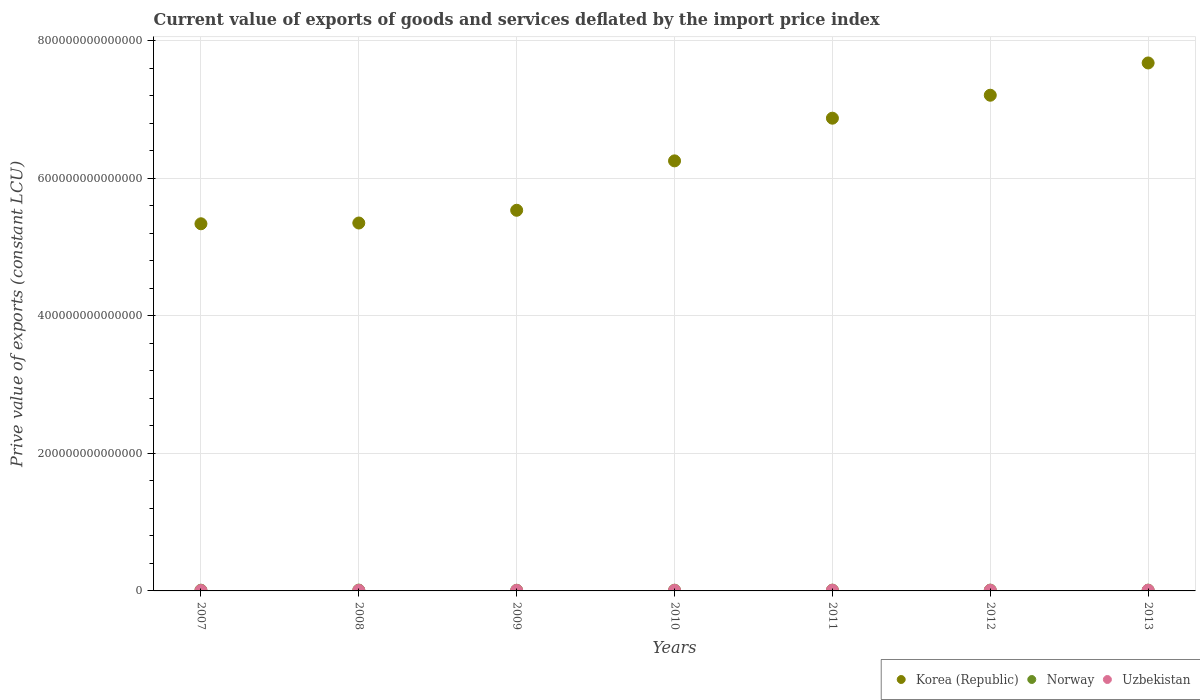What is the prive value of exports in Norway in 2013?
Ensure brevity in your answer.  1.12e+12. Across all years, what is the maximum prive value of exports in Uzbekistan?
Give a very brief answer. 1.02e+12. Across all years, what is the minimum prive value of exports in Uzbekistan?
Make the answer very short. 5.86e+11. In which year was the prive value of exports in Uzbekistan maximum?
Offer a very short reply. 2013. What is the total prive value of exports in Norway in the graph?
Provide a succinct answer. 7.67e+12. What is the difference between the prive value of exports in Norway in 2008 and that in 2013?
Give a very brief answer. 8.02e+1. What is the difference between the prive value of exports in Korea (Republic) in 2012 and the prive value of exports in Uzbekistan in 2010?
Make the answer very short. 7.20e+14. What is the average prive value of exports in Uzbekistan per year?
Provide a succinct answer. 8.49e+11. In the year 2009, what is the difference between the prive value of exports in Uzbekistan and prive value of exports in Korea (Republic)?
Ensure brevity in your answer.  -5.53e+14. In how many years, is the prive value of exports in Uzbekistan greater than 720000000000000 LCU?
Offer a very short reply. 0. What is the ratio of the prive value of exports in Norway in 2011 to that in 2013?
Your answer should be very brief. 0.99. What is the difference between the highest and the second highest prive value of exports in Korea (Republic)?
Your answer should be very brief. 4.69e+13. What is the difference between the highest and the lowest prive value of exports in Uzbekistan?
Offer a very short reply. 4.30e+11. Does the prive value of exports in Korea (Republic) monotonically increase over the years?
Your response must be concise. Yes. Is the prive value of exports in Korea (Republic) strictly greater than the prive value of exports in Norway over the years?
Keep it short and to the point. Yes. Is the prive value of exports in Uzbekistan strictly less than the prive value of exports in Norway over the years?
Offer a terse response. Yes. What is the difference between two consecutive major ticks on the Y-axis?
Provide a short and direct response. 2.00e+14. Are the values on the major ticks of Y-axis written in scientific E-notation?
Offer a terse response. No. Does the graph contain any zero values?
Make the answer very short. No. Does the graph contain grids?
Make the answer very short. Yes. How many legend labels are there?
Make the answer very short. 3. How are the legend labels stacked?
Ensure brevity in your answer.  Horizontal. What is the title of the graph?
Make the answer very short. Current value of exports of goods and services deflated by the import price index. Does "Chad" appear as one of the legend labels in the graph?
Keep it short and to the point. No. What is the label or title of the Y-axis?
Keep it short and to the point. Prive value of exports (constant LCU). What is the Prive value of exports (constant LCU) of Korea (Republic) in 2007?
Give a very brief answer. 5.34e+14. What is the Prive value of exports (constant LCU) in Norway in 2007?
Make the answer very short. 1.07e+12. What is the Prive value of exports (constant LCU) of Uzbekistan in 2007?
Your answer should be very brief. 5.86e+11. What is the Prive value of exports (constant LCU) in Korea (Republic) in 2008?
Offer a terse response. 5.35e+14. What is the Prive value of exports (constant LCU) in Norway in 2008?
Make the answer very short. 1.20e+12. What is the Prive value of exports (constant LCU) in Uzbekistan in 2008?
Your answer should be compact. 8.05e+11. What is the Prive value of exports (constant LCU) in Korea (Republic) in 2009?
Ensure brevity in your answer.  5.53e+14. What is the Prive value of exports (constant LCU) in Norway in 2009?
Ensure brevity in your answer.  9.60e+11. What is the Prive value of exports (constant LCU) in Uzbekistan in 2009?
Your response must be concise. 7.74e+11. What is the Prive value of exports (constant LCU) of Korea (Republic) in 2010?
Offer a terse response. 6.25e+14. What is the Prive value of exports (constant LCU) of Norway in 2010?
Offer a terse response. 1.03e+12. What is the Prive value of exports (constant LCU) in Uzbekistan in 2010?
Your response must be concise. 8.25e+11. What is the Prive value of exports (constant LCU) in Korea (Republic) in 2011?
Offer a very short reply. 6.87e+14. What is the Prive value of exports (constant LCU) of Norway in 2011?
Ensure brevity in your answer.  1.12e+12. What is the Prive value of exports (constant LCU) of Uzbekistan in 2011?
Ensure brevity in your answer.  9.94e+11. What is the Prive value of exports (constant LCU) of Korea (Republic) in 2012?
Offer a terse response. 7.21e+14. What is the Prive value of exports (constant LCU) of Norway in 2012?
Your answer should be very brief. 1.16e+12. What is the Prive value of exports (constant LCU) in Uzbekistan in 2012?
Offer a very short reply. 9.38e+11. What is the Prive value of exports (constant LCU) of Korea (Republic) in 2013?
Keep it short and to the point. 7.68e+14. What is the Prive value of exports (constant LCU) in Norway in 2013?
Make the answer very short. 1.12e+12. What is the Prive value of exports (constant LCU) of Uzbekistan in 2013?
Keep it short and to the point. 1.02e+12. Across all years, what is the maximum Prive value of exports (constant LCU) of Korea (Republic)?
Make the answer very short. 7.68e+14. Across all years, what is the maximum Prive value of exports (constant LCU) of Norway?
Offer a very short reply. 1.20e+12. Across all years, what is the maximum Prive value of exports (constant LCU) of Uzbekistan?
Your answer should be very brief. 1.02e+12. Across all years, what is the minimum Prive value of exports (constant LCU) in Korea (Republic)?
Your answer should be compact. 5.34e+14. Across all years, what is the minimum Prive value of exports (constant LCU) of Norway?
Your response must be concise. 9.60e+11. Across all years, what is the minimum Prive value of exports (constant LCU) in Uzbekistan?
Your answer should be very brief. 5.86e+11. What is the total Prive value of exports (constant LCU) of Korea (Republic) in the graph?
Your answer should be very brief. 4.42e+15. What is the total Prive value of exports (constant LCU) of Norway in the graph?
Give a very brief answer. 7.67e+12. What is the total Prive value of exports (constant LCU) in Uzbekistan in the graph?
Provide a succinct answer. 5.94e+12. What is the difference between the Prive value of exports (constant LCU) of Korea (Republic) in 2007 and that in 2008?
Offer a very short reply. -1.11e+12. What is the difference between the Prive value of exports (constant LCU) in Norway in 2007 and that in 2008?
Offer a very short reply. -1.37e+11. What is the difference between the Prive value of exports (constant LCU) in Uzbekistan in 2007 and that in 2008?
Ensure brevity in your answer.  -2.19e+11. What is the difference between the Prive value of exports (constant LCU) in Korea (Republic) in 2007 and that in 2009?
Provide a short and direct response. -1.96e+13. What is the difference between the Prive value of exports (constant LCU) in Norway in 2007 and that in 2009?
Ensure brevity in your answer.  1.06e+11. What is the difference between the Prive value of exports (constant LCU) of Uzbekistan in 2007 and that in 2009?
Keep it short and to the point. -1.87e+11. What is the difference between the Prive value of exports (constant LCU) of Korea (Republic) in 2007 and that in 2010?
Ensure brevity in your answer.  -9.15e+13. What is the difference between the Prive value of exports (constant LCU) in Norway in 2007 and that in 2010?
Provide a short and direct response. 3.46e+1. What is the difference between the Prive value of exports (constant LCU) of Uzbekistan in 2007 and that in 2010?
Offer a terse response. -2.39e+11. What is the difference between the Prive value of exports (constant LCU) in Korea (Republic) in 2007 and that in 2011?
Give a very brief answer. -1.54e+14. What is the difference between the Prive value of exports (constant LCU) of Norway in 2007 and that in 2011?
Make the answer very short. -5.07e+1. What is the difference between the Prive value of exports (constant LCU) in Uzbekistan in 2007 and that in 2011?
Provide a succinct answer. -4.07e+11. What is the difference between the Prive value of exports (constant LCU) of Korea (Republic) in 2007 and that in 2012?
Your answer should be compact. -1.87e+14. What is the difference between the Prive value of exports (constant LCU) in Norway in 2007 and that in 2012?
Offer a very short reply. -9.87e+1. What is the difference between the Prive value of exports (constant LCU) of Uzbekistan in 2007 and that in 2012?
Give a very brief answer. -3.52e+11. What is the difference between the Prive value of exports (constant LCU) of Korea (Republic) in 2007 and that in 2013?
Keep it short and to the point. -2.34e+14. What is the difference between the Prive value of exports (constant LCU) of Norway in 2007 and that in 2013?
Your answer should be very brief. -5.72e+1. What is the difference between the Prive value of exports (constant LCU) in Uzbekistan in 2007 and that in 2013?
Provide a short and direct response. -4.30e+11. What is the difference between the Prive value of exports (constant LCU) of Korea (Republic) in 2008 and that in 2009?
Ensure brevity in your answer.  -1.85e+13. What is the difference between the Prive value of exports (constant LCU) in Norway in 2008 and that in 2009?
Your answer should be compact. 2.43e+11. What is the difference between the Prive value of exports (constant LCU) of Uzbekistan in 2008 and that in 2009?
Make the answer very short. 3.17e+1. What is the difference between the Prive value of exports (constant LCU) in Korea (Republic) in 2008 and that in 2010?
Keep it short and to the point. -9.04e+13. What is the difference between the Prive value of exports (constant LCU) of Norway in 2008 and that in 2010?
Offer a very short reply. 1.72e+11. What is the difference between the Prive value of exports (constant LCU) in Uzbekistan in 2008 and that in 2010?
Provide a succinct answer. -1.95e+1. What is the difference between the Prive value of exports (constant LCU) in Korea (Republic) in 2008 and that in 2011?
Your answer should be compact. -1.52e+14. What is the difference between the Prive value of exports (constant LCU) of Norway in 2008 and that in 2011?
Ensure brevity in your answer.  8.67e+1. What is the difference between the Prive value of exports (constant LCU) in Uzbekistan in 2008 and that in 2011?
Give a very brief answer. -1.88e+11. What is the difference between the Prive value of exports (constant LCU) in Korea (Republic) in 2008 and that in 2012?
Offer a very short reply. -1.86e+14. What is the difference between the Prive value of exports (constant LCU) of Norway in 2008 and that in 2012?
Give a very brief answer. 3.87e+1. What is the difference between the Prive value of exports (constant LCU) in Uzbekistan in 2008 and that in 2012?
Give a very brief answer. -1.33e+11. What is the difference between the Prive value of exports (constant LCU) in Korea (Republic) in 2008 and that in 2013?
Provide a succinct answer. -2.33e+14. What is the difference between the Prive value of exports (constant LCU) in Norway in 2008 and that in 2013?
Your response must be concise. 8.02e+1. What is the difference between the Prive value of exports (constant LCU) in Uzbekistan in 2008 and that in 2013?
Your answer should be compact. -2.11e+11. What is the difference between the Prive value of exports (constant LCU) of Korea (Republic) in 2009 and that in 2010?
Keep it short and to the point. -7.18e+13. What is the difference between the Prive value of exports (constant LCU) of Norway in 2009 and that in 2010?
Keep it short and to the point. -7.09e+1. What is the difference between the Prive value of exports (constant LCU) of Uzbekistan in 2009 and that in 2010?
Make the answer very short. -5.12e+1. What is the difference between the Prive value of exports (constant LCU) of Korea (Republic) in 2009 and that in 2011?
Offer a terse response. -1.34e+14. What is the difference between the Prive value of exports (constant LCU) of Norway in 2009 and that in 2011?
Ensure brevity in your answer.  -1.56e+11. What is the difference between the Prive value of exports (constant LCU) of Uzbekistan in 2009 and that in 2011?
Provide a succinct answer. -2.20e+11. What is the difference between the Prive value of exports (constant LCU) in Korea (Republic) in 2009 and that in 2012?
Your answer should be compact. -1.67e+14. What is the difference between the Prive value of exports (constant LCU) in Norway in 2009 and that in 2012?
Offer a terse response. -2.04e+11. What is the difference between the Prive value of exports (constant LCU) in Uzbekistan in 2009 and that in 2012?
Give a very brief answer. -1.65e+11. What is the difference between the Prive value of exports (constant LCU) of Korea (Republic) in 2009 and that in 2013?
Offer a very short reply. -2.14e+14. What is the difference between the Prive value of exports (constant LCU) of Norway in 2009 and that in 2013?
Offer a very short reply. -1.63e+11. What is the difference between the Prive value of exports (constant LCU) in Uzbekistan in 2009 and that in 2013?
Give a very brief answer. -2.43e+11. What is the difference between the Prive value of exports (constant LCU) in Korea (Republic) in 2010 and that in 2011?
Provide a short and direct response. -6.21e+13. What is the difference between the Prive value of exports (constant LCU) in Norway in 2010 and that in 2011?
Provide a short and direct response. -8.54e+1. What is the difference between the Prive value of exports (constant LCU) of Uzbekistan in 2010 and that in 2011?
Give a very brief answer. -1.69e+11. What is the difference between the Prive value of exports (constant LCU) in Korea (Republic) in 2010 and that in 2012?
Give a very brief answer. -9.54e+13. What is the difference between the Prive value of exports (constant LCU) in Norway in 2010 and that in 2012?
Make the answer very short. -1.33e+11. What is the difference between the Prive value of exports (constant LCU) of Uzbekistan in 2010 and that in 2012?
Your answer should be compact. -1.14e+11. What is the difference between the Prive value of exports (constant LCU) in Korea (Republic) in 2010 and that in 2013?
Give a very brief answer. -1.42e+14. What is the difference between the Prive value of exports (constant LCU) of Norway in 2010 and that in 2013?
Provide a short and direct response. -9.18e+1. What is the difference between the Prive value of exports (constant LCU) of Uzbekistan in 2010 and that in 2013?
Give a very brief answer. -1.92e+11. What is the difference between the Prive value of exports (constant LCU) of Korea (Republic) in 2011 and that in 2012?
Offer a terse response. -3.34e+13. What is the difference between the Prive value of exports (constant LCU) of Norway in 2011 and that in 2012?
Your answer should be very brief. -4.80e+1. What is the difference between the Prive value of exports (constant LCU) of Uzbekistan in 2011 and that in 2012?
Provide a short and direct response. 5.53e+1. What is the difference between the Prive value of exports (constant LCU) of Korea (Republic) in 2011 and that in 2013?
Your answer should be very brief. -8.03e+13. What is the difference between the Prive value of exports (constant LCU) of Norway in 2011 and that in 2013?
Ensure brevity in your answer.  -6.43e+09. What is the difference between the Prive value of exports (constant LCU) of Uzbekistan in 2011 and that in 2013?
Give a very brief answer. -2.29e+1. What is the difference between the Prive value of exports (constant LCU) in Korea (Republic) in 2012 and that in 2013?
Offer a terse response. -4.69e+13. What is the difference between the Prive value of exports (constant LCU) in Norway in 2012 and that in 2013?
Ensure brevity in your answer.  4.16e+1. What is the difference between the Prive value of exports (constant LCU) of Uzbekistan in 2012 and that in 2013?
Provide a short and direct response. -7.82e+1. What is the difference between the Prive value of exports (constant LCU) in Korea (Republic) in 2007 and the Prive value of exports (constant LCU) in Norway in 2008?
Your response must be concise. 5.33e+14. What is the difference between the Prive value of exports (constant LCU) in Korea (Republic) in 2007 and the Prive value of exports (constant LCU) in Uzbekistan in 2008?
Ensure brevity in your answer.  5.33e+14. What is the difference between the Prive value of exports (constant LCU) in Norway in 2007 and the Prive value of exports (constant LCU) in Uzbekistan in 2008?
Ensure brevity in your answer.  2.61e+11. What is the difference between the Prive value of exports (constant LCU) of Korea (Republic) in 2007 and the Prive value of exports (constant LCU) of Norway in 2009?
Offer a terse response. 5.33e+14. What is the difference between the Prive value of exports (constant LCU) in Korea (Republic) in 2007 and the Prive value of exports (constant LCU) in Uzbekistan in 2009?
Offer a terse response. 5.33e+14. What is the difference between the Prive value of exports (constant LCU) of Norway in 2007 and the Prive value of exports (constant LCU) of Uzbekistan in 2009?
Make the answer very short. 2.92e+11. What is the difference between the Prive value of exports (constant LCU) in Korea (Republic) in 2007 and the Prive value of exports (constant LCU) in Norway in 2010?
Your answer should be very brief. 5.33e+14. What is the difference between the Prive value of exports (constant LCU) of Korea (Republic) in 2007 and the Prive value of exports (constant LCU) of Uzbekistan in 2010?
Your answer should be compact. 5.33e+14. What is the difference between the Prive value of exports (constant LCU) in Norway in 2007 and the Prive value of exports (constant LCU) in Uzbekistan in 2010?
Give a very brief answer. 2.41e+11. What is the difference between the Prive value of exports (constant LCU) in Korea (Republic) in 2007 and the Prive value of exports (constant LCU) in Norway in 2011?
Make the answer very short. 5.33e+14. What is the difference between the Prive value of exports (constant LCU) of Korea (Republic) in 2007 and the Prive value of exports (constant LCU) of Uzbekistan in 2011?
Offer a very short reply. 5.33e+14. What is the difference between the Prive value of exports (constant LCU) of Norway in 2007 and the Prive value of exports (constant LCU) of Uzbekistan in 2011?
Make the answer very short. 7.22e+1. What is the difference between the Prive value of exports (constant LCU) of Korea (Republic) in 2007 and the Prive value of exports (constant LCU) of Norway in 2012?
Keep it short and to the point. 5.33e+14. What is the difference between the Prive value of exports (constant LCU) of Korea (Republic) in 2007 and the Prive value of exports (constant LCU) of Uzbekistan in 2012?
Provide a succinct answer. 5.33e+14. What is the difference between the Prive value of exports (constant LCU) of Norway in 2007 and the Prive value of exports (constant LCU) of Uzbekistan in 2012?
Ensure brevity in your answer.  1.27e+11. What is the difference between the Prive value of exports (constant LCU) in Korea (Republic) in 2007 and the Prive value of exports (constant LCU) in Norway in 2013?
Provide a succinct answer. 5.33e+14. What is the difference between the Prive value of exports (constant LCU) in Korea (Republic) in 2007 and the Prive value of exports (constant LCU) in Uzbekistan in 2013?
Your answer should be compact. 5.33e+14. What is the difference between the Prive value of exports (constant LCU) in Norway in 2007 and the Prive value of exports (constant LCU) in Uzbekistan in 2013?
Ensure brevity in your answer.  4.93e+1. What is the difference between the Prive value of exports (constant LCU) of Korea (Republic) in 2008 and the Prive value of exports (constant LCU) of Norway in 2009?
Give a very brief answer. 5.34e+14. What is the difference between the Prive value of exports (constant LCU) of Korea (Republic) in 2008 and the Prive value of exports (constant LCU) of Uzbekistan in 2009?
Your response must be concise. 5.34e+14. What is the difference between the Prive value of exports (constant LCU) in Norway in 2008 and the Prive value of exports (constant LCU) in Uzbekistan in 2009?
Offer a very short reply. 4.30e+11. What is the difference between the Prive value of exports (constant LCU) of Korea (Republic) in 2008 and the Prive value of exports (constant LCU) of Norway in 2010?
Keep it short and to the point. 5.34e+14. What is the difference between the Prive value of exports (constant LCU) in Korea (Republic) in 2008 and the Prive value of exports (constant LCU) in Uzbekistan in 2010?
Ensure brevity in your answer.  5.34e+14. What is the difference between the Prive value of exports (constant LCU) of Norway in 2008 and the Prive value of exports (constant LCU) of Uzbekistan in 2010?
Offer a terse response. 3.78e+11. What is the difference between the Prive value of exports (constant LCU) in Korea (Republic) in 2008 and the Prive value of exports (constant LCU) in Norway in 2011?
Give a very brief answer. 5.34e+14. What is the difference between the Prive value of exports (constant LCU) of Korea (Republic) in 2008 and the Prive value of exports (constant LCU) of Uzbekistan in 2011?
Provide a succinct answer. 5.34e+14. What is the difference between the Prive value of exports (constant LCU) in Norway in 2008 and the Prive value of exports (constant LCU) in Uzbekistan in 2011?
Your answer should be compact. 2.10e+11. What is the difference between the Prive value of exports (constant LCU) of Korea (Republic) in 2008 and the Prive value of exports (constant LCU) of Norway in 2012?
Your response must be concise. 5.34e+14. What is the difference between the Prive value of exports (constant LCU) of Korea (Republic) in 2008 and the Prive value of exports (constant LCU) of Uzbekistan in 2012?
Keep it short and to the point. 5.34e+14. What is the difference between the Prive value of exports (constant LCU) in Norway in 2008 and the Prive value of exports (constant LCU) in Uzbekistan in 2012?
Give a very brief answer. 2.65e+11. What is the difference between the Prive value of exports (constant LCU) in Korea (Republic) in 2008 and the Prive value of exports (constant LCU) in Norway in 2013?
Provide a succinct answer. 5.34e+14. What is the difference between the Prive value of exports (constant LCU) of Korea (Republic) in 2008 and the Prive value of exports (constant LCU) of Uzbekistan in 2013?
Your answer should be compact. 5.34e+14. What is the difference between the Prive value of exports (constant LCU) in Norway in 2008 and the Prive value of exports (constant LCU) in Uzbekistan in 2013?
Ensure brevity in your answer.  1.87e+11. What is the difference between the Prive value of exports (constant LCU) of Korea (Republic) in 2009 and the Prive value of exports (constant LCU) of Norway in 2010?
Keep it short and to the point. 5.52e+14. What is the difference between the Prive value of exports (constant LCU) in Korea (Republic) in 2009 and the Prive value of exports (constant LCU) in Uzbekistan in 2010?
Keep it short and to the point. 5.53e+14. What is the difference between the Prive value of exports (constant LCU) in Norway in 2009 and the Prive value of exports (constant LCU) in Uzbekistan in 2010?
Offer a terse response. 1.35e+11. What is the difference between the Prive value of exports (constant LCU) in Korea (Republic) in 2009 and the Prive value of exports (constant LCU) in Norway in 2011?
Your answer should be compact. 5.52e+14. What is the difference between the Prive value of exports (constant LCU) in Korea (Republic) in 2009 and the Prive value of exports (constant LCU) in Uzbekistan in 2011?
Give a very brief answer. 5.52e+14. What is the difference between the Prive value of exports (constant LCU) in Norway in 2009 and the Prive value of exports (constant LCU) in Uzbekistan in 2011?
Your response must be concise. -3.33e+1. What is the difference between the Prive value of exports (constant LCU) in Korea (Republic) in 2009 and the Prive value of exports (constant LCU) in Norway in 2012?
Provide a succinct answer. 5.52e+14. What is the difference between the Prive value of exports (constant LCU) in Korea (Republic) in 2009 and the Prive value of exports (constant LCU) in Uzbekistan in 2012?
Your answer should be very brief. 5.53e+14. What is the difference between the Prive value of exports (constant LCU) of Norway in 2009 and the Prive value of exports (constant LCU) of Uzbekistan in 2012?
Ensure brevity in your answer.  2.20e+1. What is the difference between the Prive value of exports (constant LCU) of Korea (Republic) in 2009 and the Prive value of exports (constant LCU) of Norway in 2013?
Your answer should be very brief. 5.52e+14. What is the difference between the Prive value of exports (constant LCU) in Korea (Republic) in 2009 and the Prive value of exports (constant LCU) in Uzbekistan in 2013?
Keep it short and to the point. 5.52e+14. What is the difference between the Prive value of exports (constant LCU) of Norway in 2009 and the Prive value of exports (constant LCU) of Uzbekistan in 2013?
Your answer should be very brief. -5.62e+1. What is the difference between the Prive value of exports (constant LCU) of Korea (Republic) in 2010 and the Prive value of exports (constant LCU) of Norway in 2011?
Ensure brevity in your answer.  6.24e+14. What is the difference between the Prive value of exports (constant LCU) of Korea (Republic) in 2010 and the Prive value of exports (constant LCU) of Uzbekistan in 2011?
Offer a terse response. 6.24e+14. What is the difference between the Prive value of exports (constant LCU) of Norway in 2010 and the Prive value of exports (constant LCU) of Uzbekistan in 2011?
Your answer should be compact. 3.76e+1. What is the difference between the Prive value of exports (constant LCU) in Korea (Republic) in 2010 and the Prive value of exports (constant LCU) in Norway in 2012?
Provide a short and direct response. 6.24e+14. What is the difference between the Prive value of exports (constant LCU) of Korea (Republic) in 2010 and the Prive value of exports (constant LCU) of Uzbekistan in 2012?
Offer a very short reply. 6.24e+14. What is the difference between the Prive value of exports (constant LCU) in Norway in 2010 and the Prive value of exports (constant LCU) in Uzbekistan in 2012?
Provide a succinct answer. 9.29e+1. What is the difference between the Prive value of exports (constant LCU) in Korea (Republic) in 2010 and the Prive value of exports (constant LCU) in Norway in 2013?
Offer a terse response. 6.24e+14. What is the difference between the Prive value of exports (constant LCU) in Korea (Republic) in 2010 and the Prive value of exports (constant LCU) in Uzbekistan in 2013?
Give a very brief answer. 6.24e+14. What is the difference between the Prive value of exports (constant LCU) of Norway in 2010 and the Prive value of exports (constant LCU) of Uzbekistan in 2013?
Give a very brief answer. 1.47e+1. What is the difference between the Prive value of exports (constant LCU) of Korea (Republic) in 2011 and the Prive value of exports (constant LCU) of Norway in 2012?
Your response must be concise. 6.86e+14. What is the difference between the Prive value of exports (constant LCU) of Korea (Republic) in 2011 and the Prive value of exports (constant LCU) of Uzbekistan in 2012?
Provide a succinct answer. 6.86e+14. What is the difference between the Prive value of exports (constant LCU) of Norway in 2011 and the Prive value of exports (constant LCU) of Uzbekistan in 2012?
Your answer should be very brief. 1.78e+11. What is the difference between the Prive value of exports (constant LCU) in Korea (Republic) in 2011 and the Prive value of exports (constant LCU) in Norway in 2013?
Make the answer very short. 6.86e+14. What is the difference between the Prive value of exports (constant LCU) in Korea (Republic) in 2011 and the Prive value of exports (constant LCU) in Uzbekistan in 2013?
Your response must be concise. 6.86e+14. What is the difference between the Prive value of exports (constant LCU) of Norway in 2011 and the Prive value of exports (constant LCU) of Uzbekistan in 2013?
Give a very brief answer. 1.00e+11. What is the difference between the Prive value of exports (constant LCU) in Korea (Republic) in 2012 and the Prive value of exports (constant LCU) in Norway in 2013?
Make the answer very short. 7.20e+14. What is the difference between the Prive value of exports (constant LCU) of Korea (Republic) in 2012 and the Prive value of exports (constant LCU) of Uzbekistan in 2013?
Your response must be concise. 7.20e+14. What is the difference between the Prive value of exports (constant LCU) of Norway in 2012 and the Prive value of exports (constant LCU) of Uzbekistan in 2013?
Your response must be concise. 1.48e+11. What is the average Prive value of exports (constant LCU) in Korea (Republic) per year?
Give a very brief answer. 6.32e+14. What is the average Prive value of exports (constant LCU) of Norway per year?
Your answer should be very brief. 1.10e+12. What is the average Prive value of exports (constant LCU) in Uzbekistan per year?
Offer a very short reply. 8.49e+11. In the year 2007, what is the difference between the Prive value of exports (constant LCU) of Korea (Republic) and Prive value of exports (constant LCU) of Norway?
Make the answer very short. 5.33e+14. In the year 2007, what is the difference between the Prive value of exports (constant LCU) in Korea (Republic) and Prive value of exports (constant LCU) in Uzbekistan?
Provide a succinct answer. 5.33e+14. In the year 2007, what is the difference between the Prive value of exports (constant LCU) in Norway and Prive value of exports (constant LCU) in Uzbekistan?
Keep it short and to the point. 4.80e+11. In the year 2008, what is the difference between the Prive value of exports (constant LCU) in Korea (Republic) and Prive value of exports (constant LCU) in Norway?
Keep it short and to the point. 5.34e+14. In the year 2008, what is the difference between the Prive value of exports (constant LCU) in Korea (Republic) and Prive value of exports (constant LCU) in Uzbekistan?
Your answer should be very brief. 5.34e+14. In the year 2008, what is the difference between the Prive value of exports (constant LCU) of Norway and Prive value of exports (constant LCU) of Uzbekistan?
Offer a very short reply. 3.98e+11. In the year 2009, what is the difference between the Prive value of exports (constant LCU) of Korea (Republic) and Prive value of exports (constant LCU) of Norway?
Provide a succinct answer. 5.53e+14. In the year 2009, what is the difference between the Prive value of exports (constant LCU) in Korea (Republic) and Prive value of exports (constant LCU) in Uzbekistan?
Your answer should be very brief. 5.53e+14. In the year 2009, what is the difference between the Prive value of exports (constant LCU) in Norway and Prive value of exports (constant LCU) in Uzbekistan?
Give a very brief answer. 1.87e+11. In the year 2010, what is the difference between the Prive value of exports (constant LCU) in Korea (Republic) and Prive value of exports (constant LCU) in Norway?
Give a very brief answer. 6.24e+14. In the year 2010, what is the difference between the Prive value of exports (constant LCU) in Korea (Republic) and Prive value of exports (constant LCU) in Uzbekistan?
Ensure brevity in your answer.  6.24e+14. In the year 2010, what is the difference between the Prive value of exports (constant LCU) of Norway and Prive value of exports (constant LCU) of Uzbekistan?
Ensure brevity in your answer.  2.06e+11. In the year 2011, what is the difference between the Prive value of exports (constant LCU) of Korea (Republic) and Prive value of exports (constant LCU) of Norway?
Your answer should be compact. 6.86e+14. In the year 2011, what is the difference between the Prive value of exports (constant LCU) of Korea (Republic) and Prive value of exports (constant LCU) of Uzbekistan?
Your response must be concise. 6.86e+14. In the year 2011, what is the difference between the Prive value of exports (constant LCU) in Norway and Prive value of exports (constant LCU) in Uzbekistan?
Give a very brief answer. 1.23e+11. In the year 2012, what is the difference between the Prive value of exports (constant LCU) in Korea (Republic) and Prive value of exports (constant LCU) in Norway?
Offer a very short reply. 7.20e+14. In the year 2012, what is the difference between the Prive value of exports (constant LCU) of Korea (Republic) and Prive value of exports (constant LCU) of Uzbekistan?
Offer a terse response. 7.20e+14. In the year 2012, what is the difference between the Prive value of exports (constant LCU) of Norway and Prive value of exports (constant LCU) of Uzbekistan?
Make the answer very short. 2.26e+11. In the year 2013, what is the difference between the Prive value of exports (constant LCU) of Korea (Republic) and Prive value of exports (constant LCU) of Norway?
Keep it short and to the point. 7.67e+14. In the year 2013, what is the difference between the Prive value of exports (constant LCU) in Korea (Republic) and Prive value of exports (constant LCU) in Uzbekistan?
Make the answer very short. 7.67e+14. In the year 2013, what is the difference between the Prive value of exports (constant LCU) of Norway and Prive value of exports (constant LCU) of Uzbekistan?
Ensure brevity in your answer.  1.06e+11. What is the ratio of the Prive value of exports (constant LCU) in Norway in 2007 to that in 2008?
Ensure brevity in your answer.  0.89. What is the ratio of the Prive value of exports (constant LCU) in Uzbekistan in 2007 to that in 2008?
Your response must be concise. 0.73. What is the ratio of the Prive value of exports (constant LCU) of Korea (Republic) in 2007 to that in 2009?
Your answer should be very brief. 0.96. What is the ratio of the Prive value of exports (constant LCU) in Norway in 2007 to that in 2009?
Offer a very short reply. 1.11. What is the ratio of the Prive value of exports (constant LCU) of Uzbekistan in 2007 to that in 2009?
Keep it short and to the point. 0.76. What is the ratio of the Prive value of exports (constant LCU) of Korea (Republic) in 2007 to that in 2010?
Make the answer very short. 0.85. What is the ratio of the Prive value of exports (constant LCU) in Norway in 2007 to that in 2010?
Make the answer very short. 1.03. What is the ratio of the Prive value of exports (constant LCU) of Uzbekistan in 2007 to that in 2010?
Offer a very short reply. 0.71. What is the ratio of the Prive value of exports (constant LCU) in Korea (Republic) in 2007 to that in 2011?
Ensure brevity in your answer.  0.78. What is the ratio of the Prive value of exports (constant LCU) in Norway in 2007 to that in 2011?
Give a very brief answer. 0.95. What is the ratio of the Prive value of exports (constant LCU) of Uzbekistan in 2007 to that in 2011?
Provide a succinct answer. 0.59. What is the ratio of the Prive value of exports (constant LCU) of Korea (Republic) in 2007 to that in 2012?
Your answer should be compact. 0.74. What is the ratio of the Prive value of exports (constant LCU) in Norway in 2007 to that in 2012?
Offer a very short reply. 0.92. What is the ratio of the Prive value of exports (constant LCU) in Uzbekistan in 2007 to that in 2012?
Make the answer very short. 0.62. What is the ratio of the Prive value of exports (constant LCU) in Korea (Republic) in 2007 to that in 2013?
Offer a very short reply. 0.7. What is the ratio of the Prive value of exports (constant LCU) of Norway in 2007 to that in 2013?
Give a very brief answer. 0.95. What is the ratio of the Prive value of exports (constant LCU) of Uzbekistan in 2007 to that in 2013?
Keep it short and to the point. 0.58. What is the ratio of the Prive value of exports (constant LCU) of Korea (Republic) in 2008 to that in 2009?
Your answer should be very brief. 0.97. What is the ratio of the Prive value of exports (constant LCU) of Norway in 2008 to that in 2009?
Give a very brief answer. 1.25. What is the ratio of the Prive value of exports (constant LCU) in Uzbekistan in 2008 to that in 2009?
Provide a succinct answer. 1.04. What is the ratio of the Prive value of exports (constant LCU) of Korea (Republic) in 2008 to that in 2010?
Your response must be concise. 0.86. What is the ratio of the Prive value of exports (constant LCU) of Norway in 2008 to that in 2010?
Provide a succinct answer. 1.17. What is the ratio of the Prive value of exports (constant LCU) of Uzbekistan in 2008 to that in 2010?
Keep it short and to the point. 0.98. What is the ratio of the Prive value of exports (constant LCU) in Korea (Republic) in 2008 to that in 2011?
Offer a terse response. 0.78. What is the ratio of the Prive value of exports (constant LCU) of Norway in 2008 to that in 2011?
Your answer should be compact. 1.08. What is the ratio of the Prive value of exports (constant LCU) in Uzbekistan in 2008 to that in 2011?
Give a very brief answer. 0.81. What is the ratio of the Prive value of exports (constant LCU) of Korea (Republic) in 2008 to that in 2012?
Give a very brief answer. 0.74. What is the ratio of the Prive value of exports (constant LCU) of Norway in 2008 to that in 2012?
Keep it short and to the point. 1.03. What is the ratio of the Prive value of exports (constant LCU) in Uzbekistan in 2008 to that in 2012?
Offer a terse response. 0.86. What is the ratio of the Prive value of exports (constant LCU) of Korea (Republic) in 2008 to that in 2013?
Make the answer very short. 0.7. What is the ratio of the Prive value of exports (constant LCU) in Norway in 2008 to that in 2013?
Your answer should be very brief. 1.07. What is the ratio of the Prive value of exports (constant LCU) in Uzbekistan in 2008 to that in 2013?
Ensure brevity in your answer.  0.79. What is the ratio of the Prive value of exports (constant LCU) in Korea (Republic) in 2009 to that in 2010?
Ensure brevity in your answer.  0.89. What is the ratio of the Prive value of exports (constant LCU) of Norway in 2009 to that in 2010?
Ensure brevity in your answer.  0.93. What is the ratio of the Prive value of exports (constant LCU) of Uzbekistan in 2009 to that in 2010?
Your response must be concise. 0.94. What is the ratio of the Prive value of exports (constant LCU) of Korea (Republic) in 2009 to that in 2011?
Your response must be concise. 0.81. What is the ratio of the Prive value of exports (constant LCU) of Norway in 2009 to that in 2011?
Give a very brief answer. 0.86. What is the ratio of the Prive value of exports (constant LCU) of Uzbekistan in 2009 to that in 2011?
Offer a terse response. 0.78. What is the ratio of the Prive value of exports (constant LCU) in Korea (Republic) in 2009 to that in 2012?
Your answer should be very brief. 0.77. What is the ratio of the Prive value of exports (constant LCU) in Norway in 2009 to that in 2012?
Ensure brevity in your answer.  0.82. What is the ratio of the Prive value of exports (constant LCU) in Uzbekistan in 2009 to that in 2012?
Your answer should be very brief. 0.82. What is the ratio of the Prive value of exports (constant LCU) in Korea (Republic) in 2009 to that in 2013?
Provide a succinct answer. 0.72. What is the ratio of the Prive value of exports (constant LCU) in Norway in 2009 to that in 2013?
Keep it short and to the point. 0.86. What is the ratio of the Prive value of exports (constant LCU) in Uzbekistan in 2009 to that in 2013?
Keep it short and to the point. 0.76. What is the ratio of the Prive value of exports (constant LCU) in Korea (Republic) in 2010 to that in 2011?
Offer a very short reply. 0.91. What is the ratio of the Prive value of exports (constant LCU) of Norway in 2010 to that in 2011?
Keep it short and to the point. 0.92. What is the ratio of the Prive value of exports (constant LCU) in Uzbekistan in 2010 to that in 2011?
Provide a succinct answer. 0.83. What is the ratio of the Prive value of exports (constant LCU) of Korea (Republic) in 2010 to that in 2012?
Ensure brevity in your answer.  0.87. What is the ratio of the Prive value of exports (constant LCU) of Norway in 2010 to that in 2012?
Offer a terse response. 0.89. What is the ratio of the Prive value of exports (constant LCU) in Uzbekistan in 2010 to that in 2012?
Offer a terse response. 0.88. What is the ratio of the Prive value of exports (constant LCU) in Korea (Republic) in 2010 to that in 2013?
Offer a terse response. 0.81. What is the ratio of the Prive value of exports (constant LCU) of Norway in 2010 to that in 2013?
Your answer should be very brief. 0.92. What is the ratio of the Prive value of exports (constant LCU) in Uzbekistan in 2010 to that in 2013?
Your answer should be very brief. 0.81. What is the ratio of the Prive value of exports (constant LCU) in Korea (Republic) in 2011 to that in 2012?
Make the answer very short. 0.95. What is the ratio of the Prive value of exports (constant LCU) of Norway in 2011 to that in 2012?
Ensure brevity in your answer.  0.96. What is the ratio of the Prive value of exports (constant LCU) in Uzbekistan in 2011 to that in 2012?
Provide a short and direct response. 1.06. What is the ratio of the Prive value of exports (constant LCU) in Korea (Republic) in 2011 to that in 2013?
Provide a short and direct response. 0.9. What is the ratio of the Prive value of exports (constant LCU) in Uzbekistan in 2011 to that in 2013?
Keep it short and to the point. 0.98. What is the ratio of the Prive value of exports (constant LCU) of Korea (Republic) in 2012 to that in 2013?
Offer a very short reply. 0.94. What is the ratio of the Prive value of exports (constant LCU) of Uzbekistan in 2012 to that in 2013?
Ensure brevity in your answer.  0.92. What is the difference between the highest and the second highest Prive value of exports (constant LCU) in Korea (Republic)?
Ensure brevity in your answer.  4.69e+13. What is the difference between the highest and the second highest Prive value of exports (constant LCU) of Norway?
Your response must be concise. 3.87e+1. What is the difference between the highest and the second highest Prive value of exports (constant LCU) of Uzbekistan?
Ensure brevity in your answer.  2.29e+1. What is the difference between the highest and the lowest Prive value of exports (constant LCU) of Korea (Republic)?
Ensure brevity in your answer.  2.34e+14. What is the difference between the highest and the lowest Prive value of exports (constant LCU) of Norway?
Offer a very short reply. 2.43e+11. What is the difference between the highest and the lowest Prive value of exports (constant LCU) in Uzbekistan?
Keep it short and to the point. 4.30e+11. 